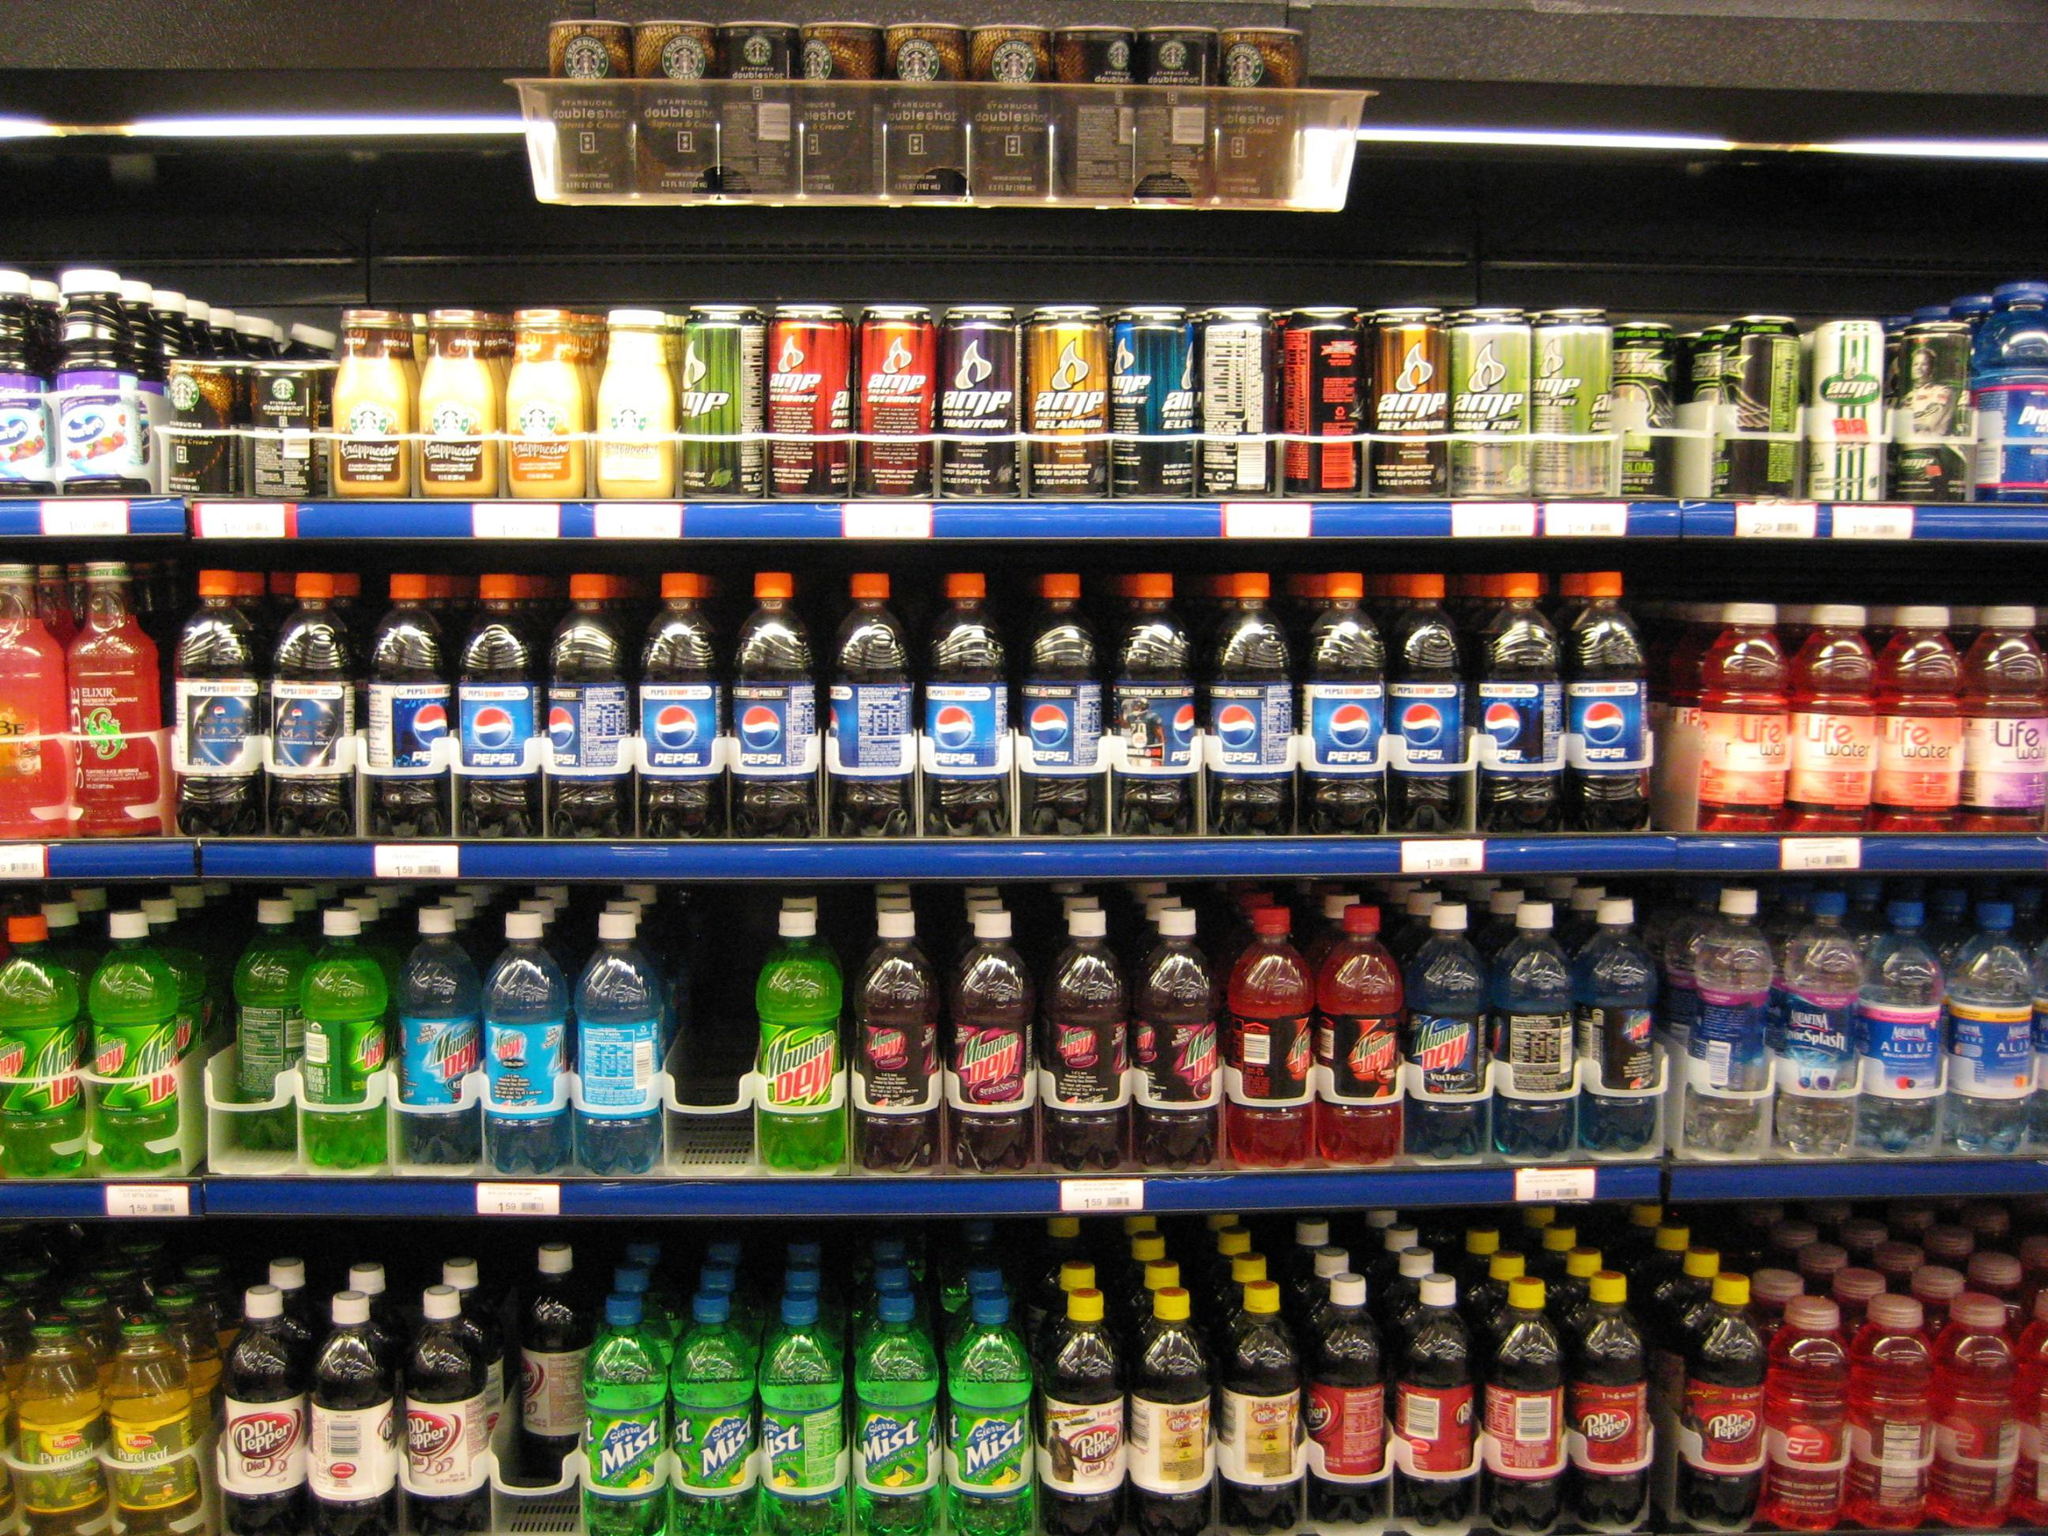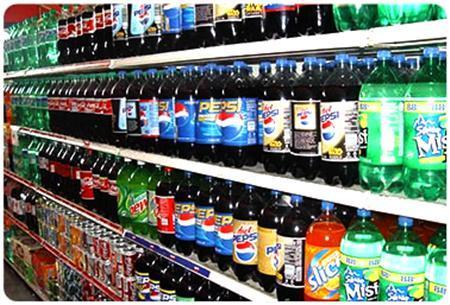The first image is the image on the left, the second image is the image on the right. For the images displayed, is the sentence "One image features sodas on shelves with at least one white card on a shelf edge, and the other image features sodas on shelves with yellow cards on the edges." factually correct? Answer yes or no. No. 